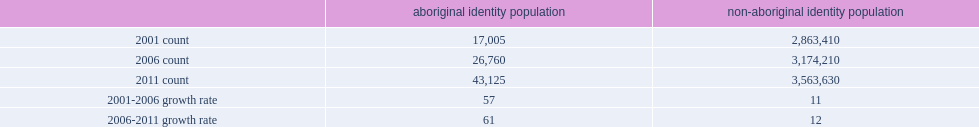How many numbers of aboriginal seniors in population centres are increased from 2001 to 2006? 57. What is the growth rate for the non-aboriginal senior population in population centres from 2001 to 2006? 11. How many percent of the total number of aboriginal seniors in population centres is increased from 2006 to 2011? 61. 